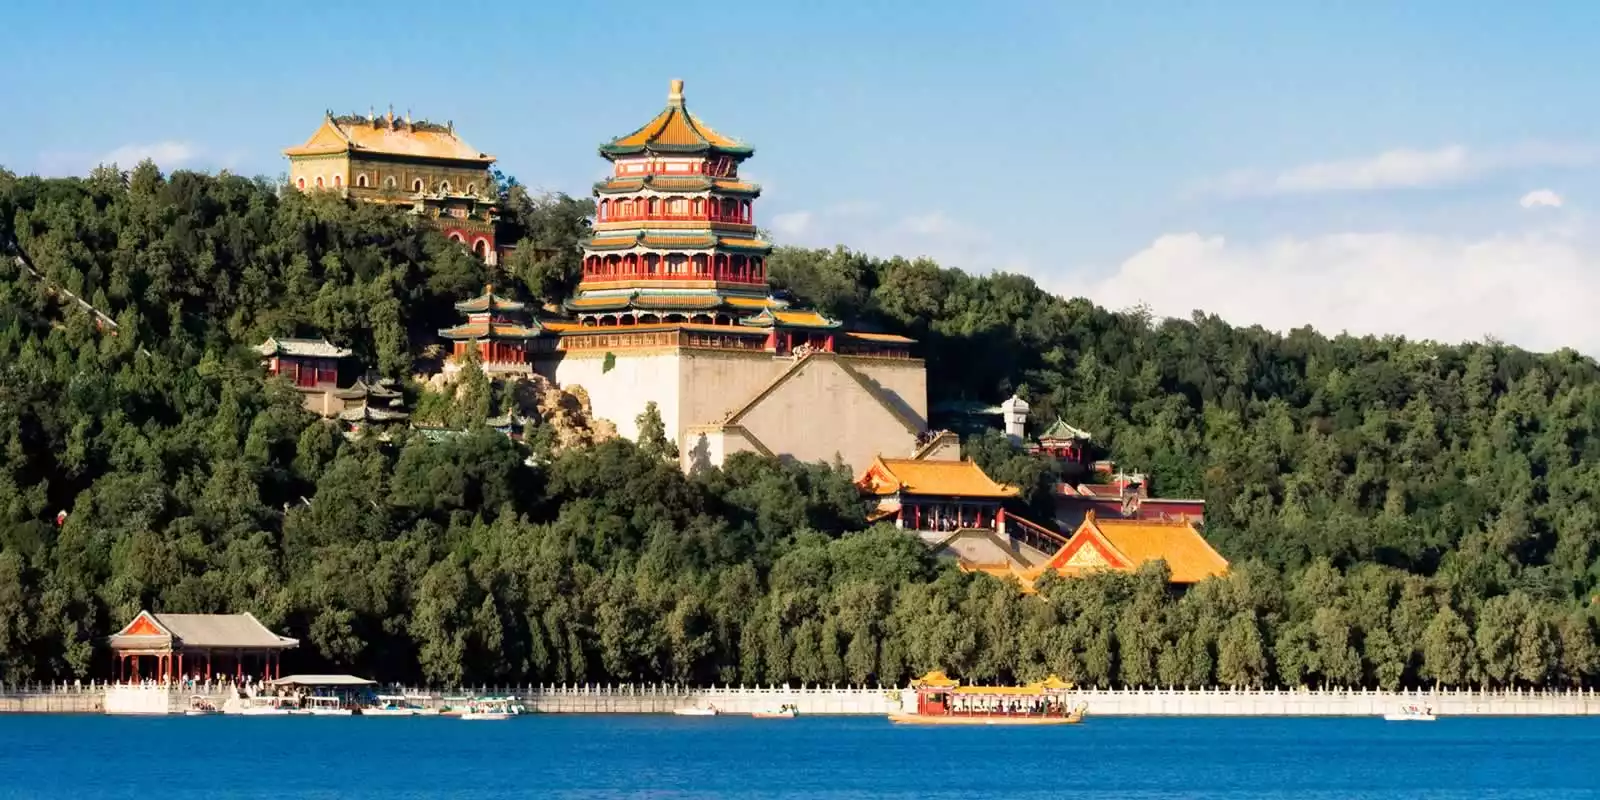Imagine a day in the life of an emperor residing in the Summer Palace. As dawn breaks over the serene lake, casting a golden hue upon the lush landscape, the emperor rises in his opulent quarters within the Summer Palace. He begins the day with a quiet meditation session in the Hall of Benevolence and Longevity, seeking tranquility and wisdom. Breakfast is a ceremonial affair, featuring an array of delicacies prepared by master chefs. The morning is spent addressing state affairs with high-ranking officials in the majestic administrative halls. Midday, the emperor strolls through the meticulously landscaped gardens, finding solace among the ancient trees and lotus ponds. Afternoons might be devoted to cultural pursuits—an enthralling opera performance or a contemplative tea ceremony in one of the airy pavilions. As the sun sets, the emperor enjoys a leisurely boat ride on Kunming Lake, absorbing the tranquil beauty of the palace lit by the warm glow of dusk. The day concludes with a lavish banquet in the Tower of Buddhist Incense, where the emperor dines with his consorts and closest advisors, reflecting on the day amidst the serenity and grandeur of his summer abode. 